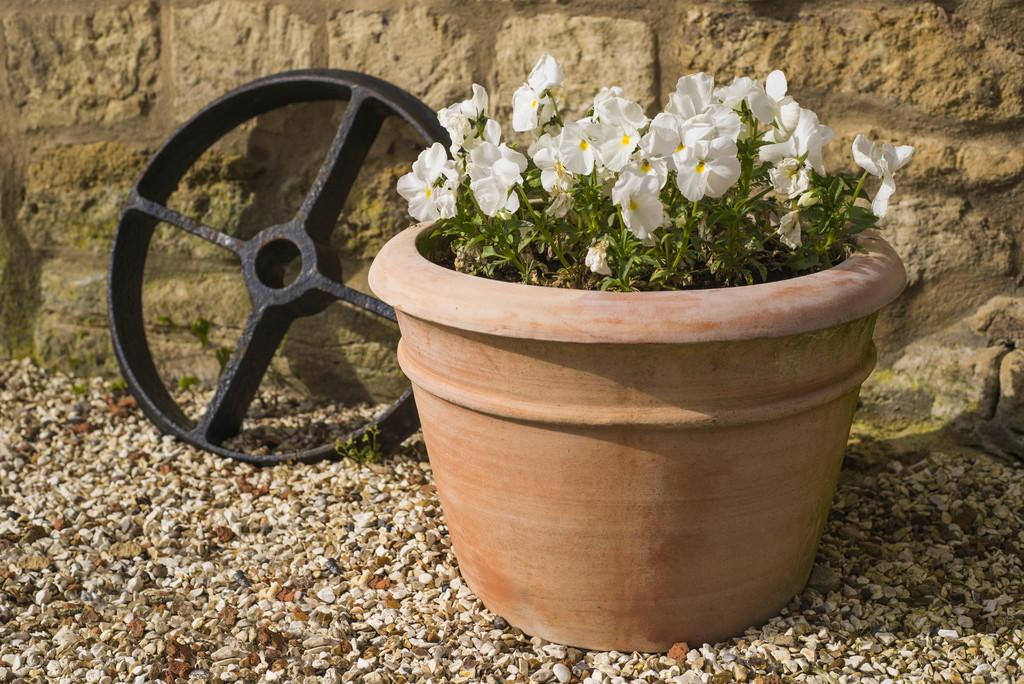What type of plant can be seen in the image? There is a plant with flowers in a pot in the image. What material is the object in the image made of? The object in the image is made of metal. What can be seen on the ground in the image? The ground is visible in the image with some objects. What is visible in the background of the image? There is a wall in the background of the image. What type of verse can be seen written on the plant in the image? There is no verse written on the plant in the image; it is a plant with flowers in a pot. 